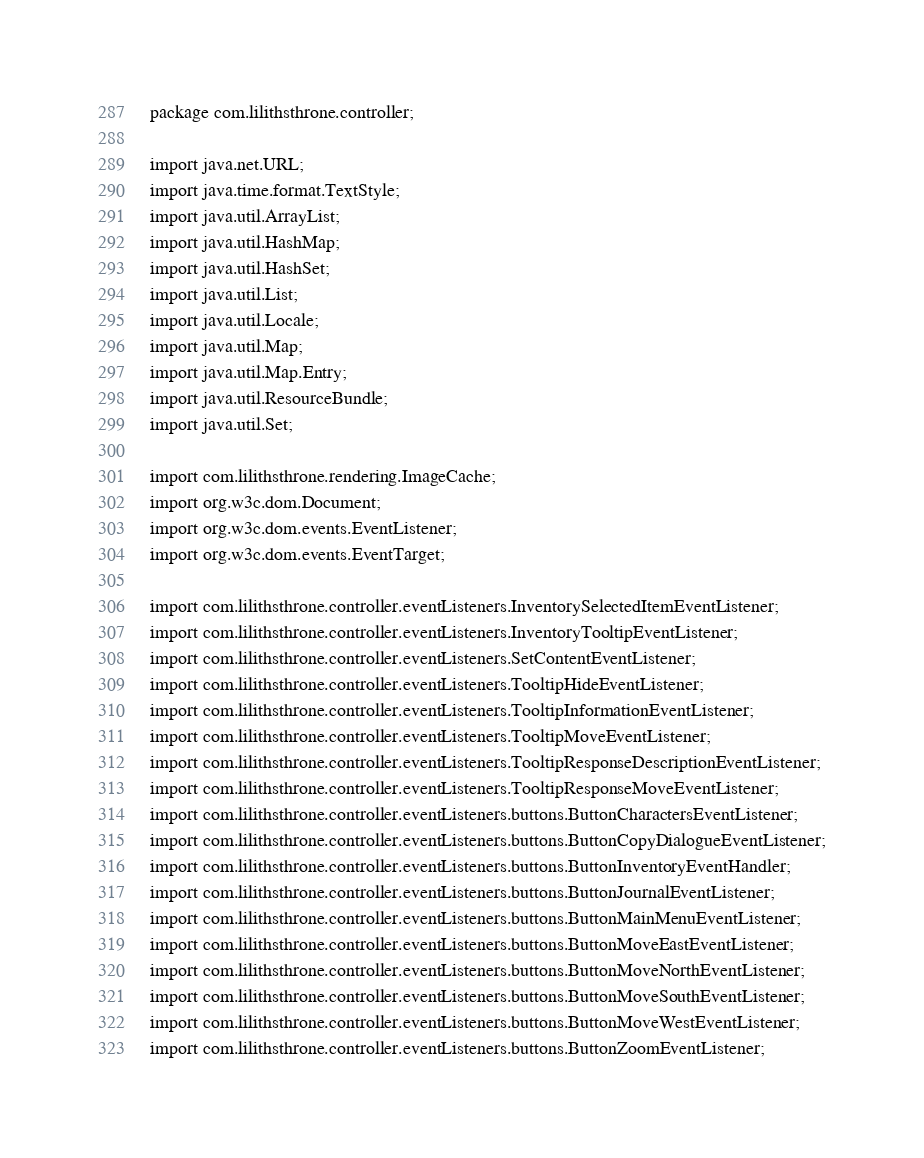<code> <loc_0><loc_0><loc_500><loc_500><_Java_>package com.lilithsthrone.controller;

import java.net.URL;
import java.time.format.TextStyle;
import java.util.ArrayList;
import java.util.HashMap;
import java.util.HashSet;
import java.util.List;
import java.util.Locale;
import java.util.Map;
import java.util.Map.Entry;
import java.util.ResourceBundle;
import java.util.Set;

import com.lilithsthrone.rendering.ImageCache;
import org.w3c.dom.Document;
import org.w3c.dom.events.EventListener;
import org.w3c.dom.events.EventTarget;

import com.lilithsthrone.controller.eventListeners.InventorySelectedItemEventListener;
import com.lilithsthrone.controller.eventListeners.InventoryTooltipEventListener;
import com.lilithsthrone.controller.eventListeners.SetContentEventListener;
import com.lilithsthrone.controller.eventListeners.TooltipHideEventListener;
import com.lilithsthrone.controller.eventListeners.TooltipInformationEventListener;
import com.lilithsthrone.controller.eventListeners.TooltipMoveEventListener;
import com.lilithsthrone.controller.eventListeners.TooltipResponseDescriptionEventListener;
import com.lilithsthrone.controller.eventListeners.TooltipResponseMoveEventListener;
import com.lilithsthrone.controller.eventListeners.buttons.ButtonCharactersEventListener;
import com.lilithsthrone.controller.eventListeners.buttons.ButtonCopyDialogueEventListener;
import com.lilithsthrone.controller.eventListeners.buttons.ButtonInventoryEventHandler;
import com.lilithsthrone.controller.eventListeners.buttons.ButtonJournalEventListener;
import com.lilithsthrone.controller.eventListeners.buttons.ButtonMainMenuEventListener;
import com.lilithsthrone.controller.eventListeners.buttons.ButtonMoveEastEventListener;
import com.lilithsthrone.controller.eventListeners.buttons.ButtonMoveNorthEventListener;
import com.lilithsthrone.controller.eventListeners.buttons.ButtonMoveSouthEventListener;
import com.lilithsthrone.controller.eventListeners.buttons.ButtonMoveWestEventListener;
import com.lilithsthrone.controller.eventListeners.buttons.ButtonZoomEventListener;</code> 